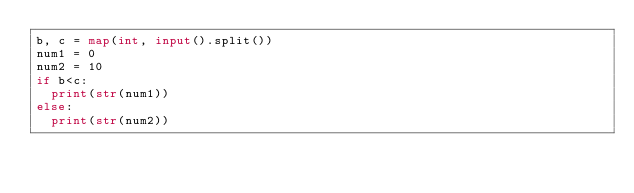<code> <loc_0><loc_0><loc_500><loc_500><_Python_>b, c = map(int, input().split())
num1 = 0
num2 = 10
if b<c:
  print(str(num1))
else:
  print(str(num2))
  
</code> 